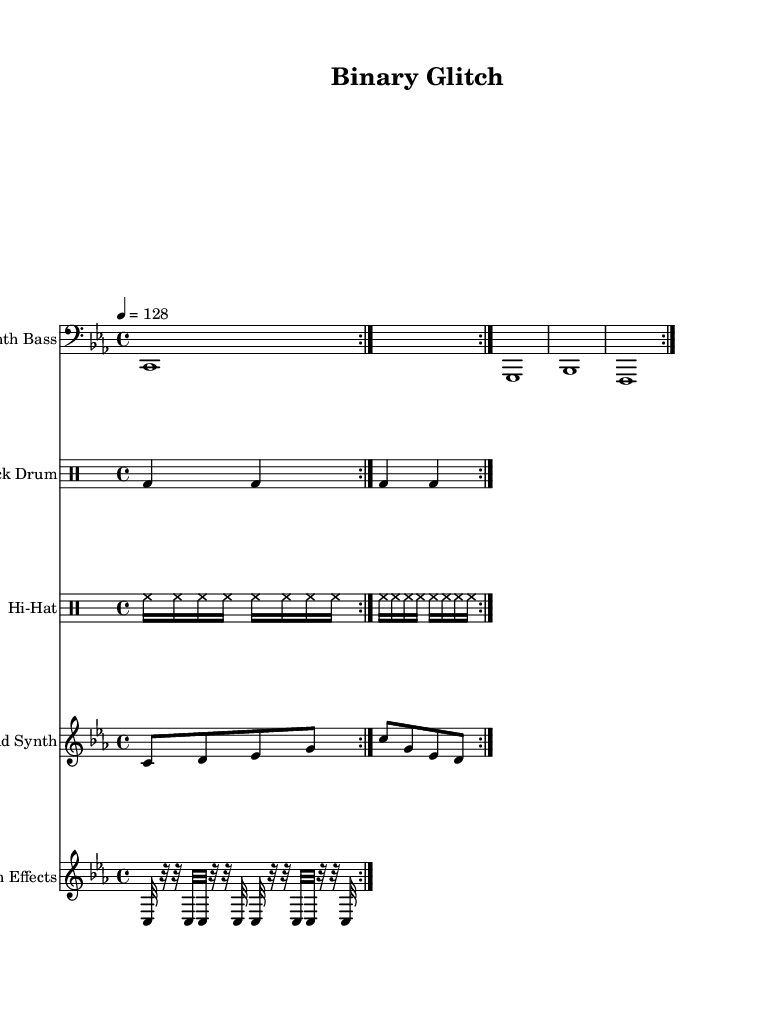What is the key signature of this music? The key signature is C minor, which includes three flats (B flat, E flat, and A flat). This can be identified in the global section of the music where the key is specified.
Answer: C minor What is the time signature of the piece? The time signature is 4/4, which is indicated in the global section of the code. This means there are four beats in each measure and a quarter note gets one beat.
Answer: 4/4 What is the tempo marking for this piece? The tempo marking is 128 beats per minute, shown as "4 = 128" in the global section. This indicates the speed at which the piece should be played.
Answer: 128 How many repetitions does the synth bass part have? The synth bass part has two repetitions, as indicated by the "repeat volta 2" section around the synth bass notes. This means the entire section will be played twice.
Answer: 2 What type of drum pattern is used for the kick drum? The kick drum uses a four-on-the-floor pattern, which is characterized by the kick drum hitting on every beat in a 4/4 measure. This can be seen from the drummode section where "bd4" is repeated in every beat.
Answer: Four-on-the-floor Which element in the music represents glitch effects? The glitch effects are represented by the section containing rapid notes and rests, such as "c32 r32 r32 c32", which gives a stuttering rhythmic quality typical of glitch music. This identification comes from the specific notes and their durations under the glitch effects staff.
Answer: Glitch effects What is the main instrument used for the lead part? The main instrument for the lead part is the synth, indicated by "Lead Synth" in the staff name, and its melody consists of notes played in a high pitch range relative to the bass. This can be confirmed from the staff that contains the lead synth melody.
Answer: Synth 